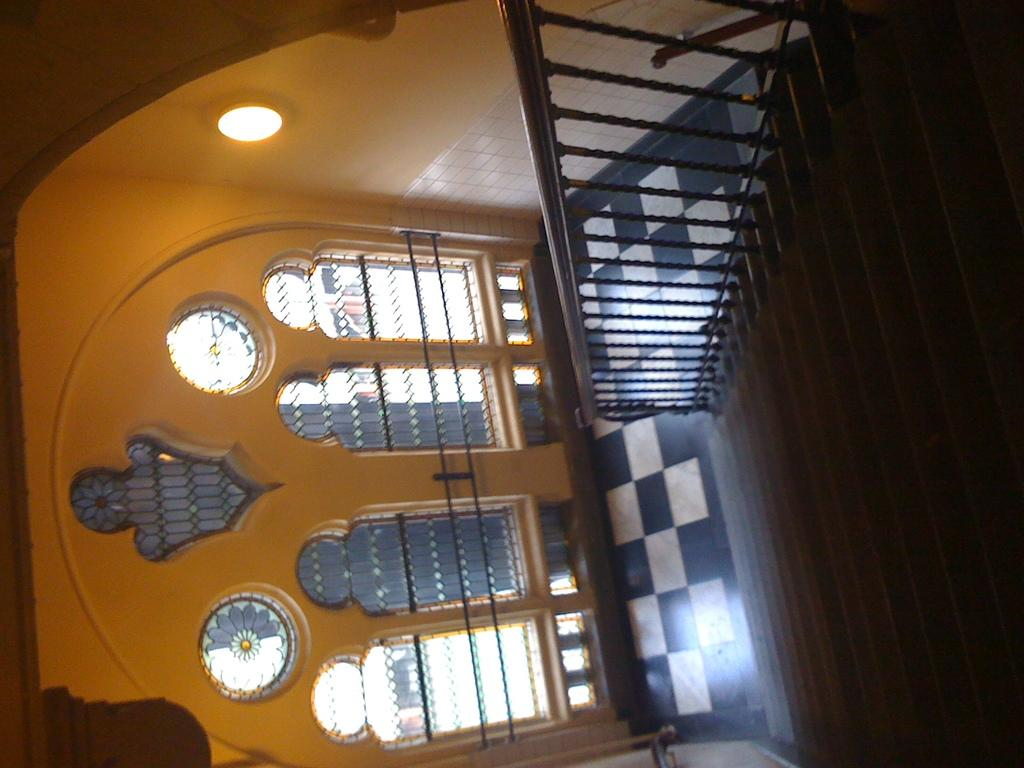What type of architectural feature is present in the image? There is a staircase in the image. What can be seen on the wall in the image? There are windows on the wall in the image. What type of nest can be seen in the eye of the person in the image? There is no person or eye present in the image, so there is no nest to be seen. 